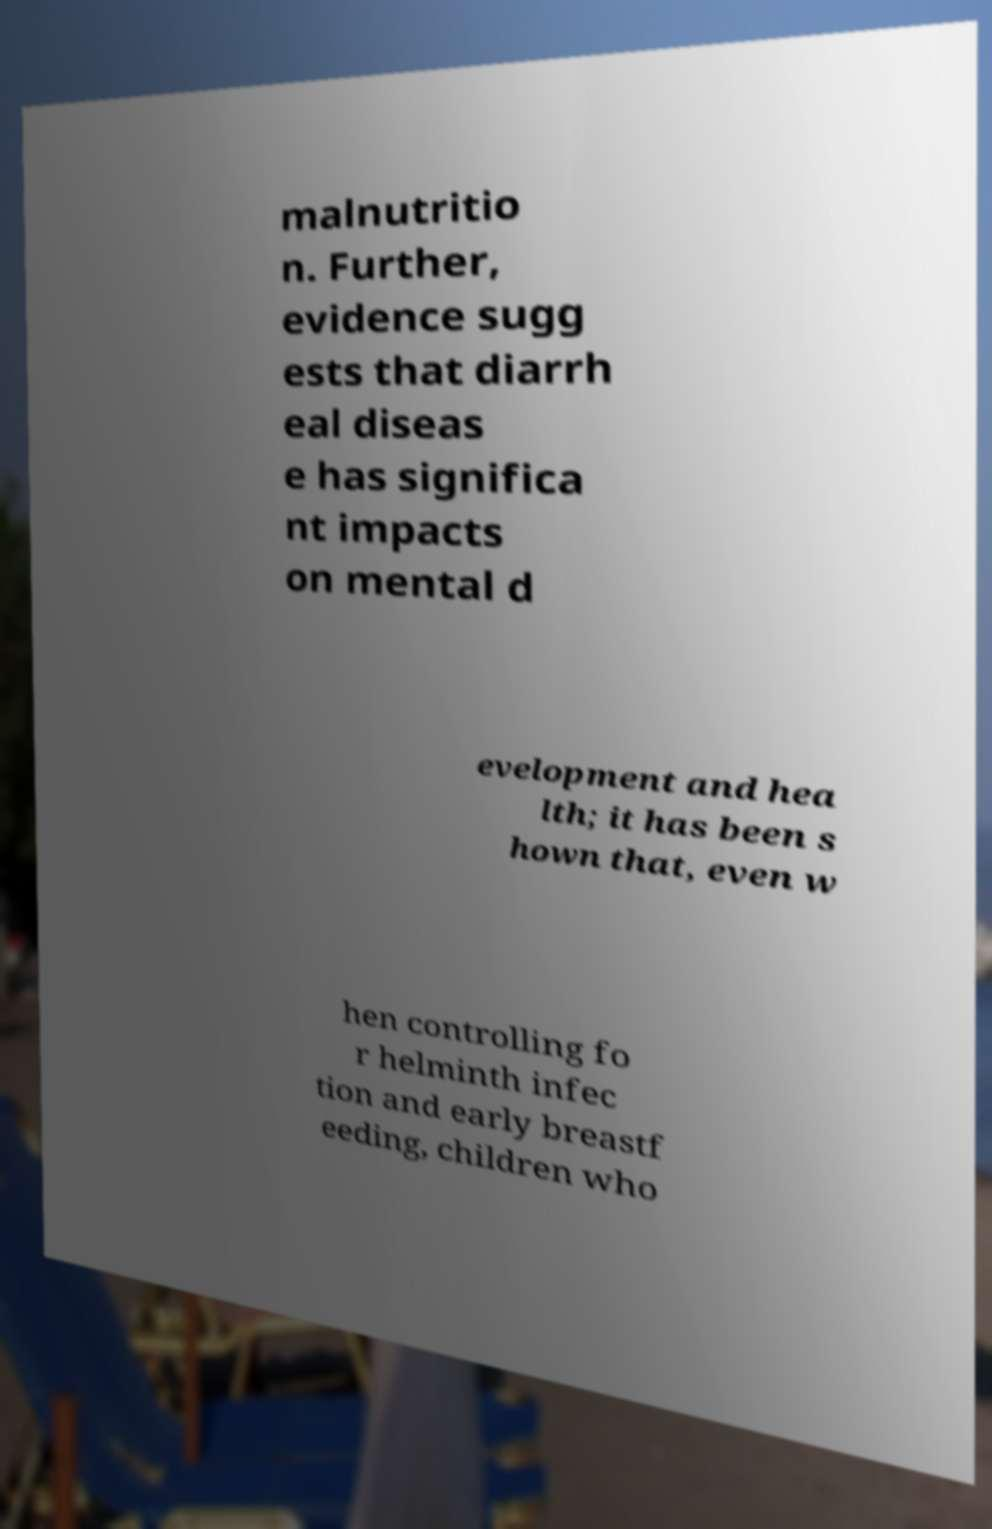Can you accurately transcribe the text from the provided image for me? malnutritio n. Further, evidence sugg ests that diarrh eal diseas e has significa nt impacts on mental d evelopment and hea lth; it has been s hown that, even w hen controlling fo r helminth infec tion and early breastf eeding, children who 